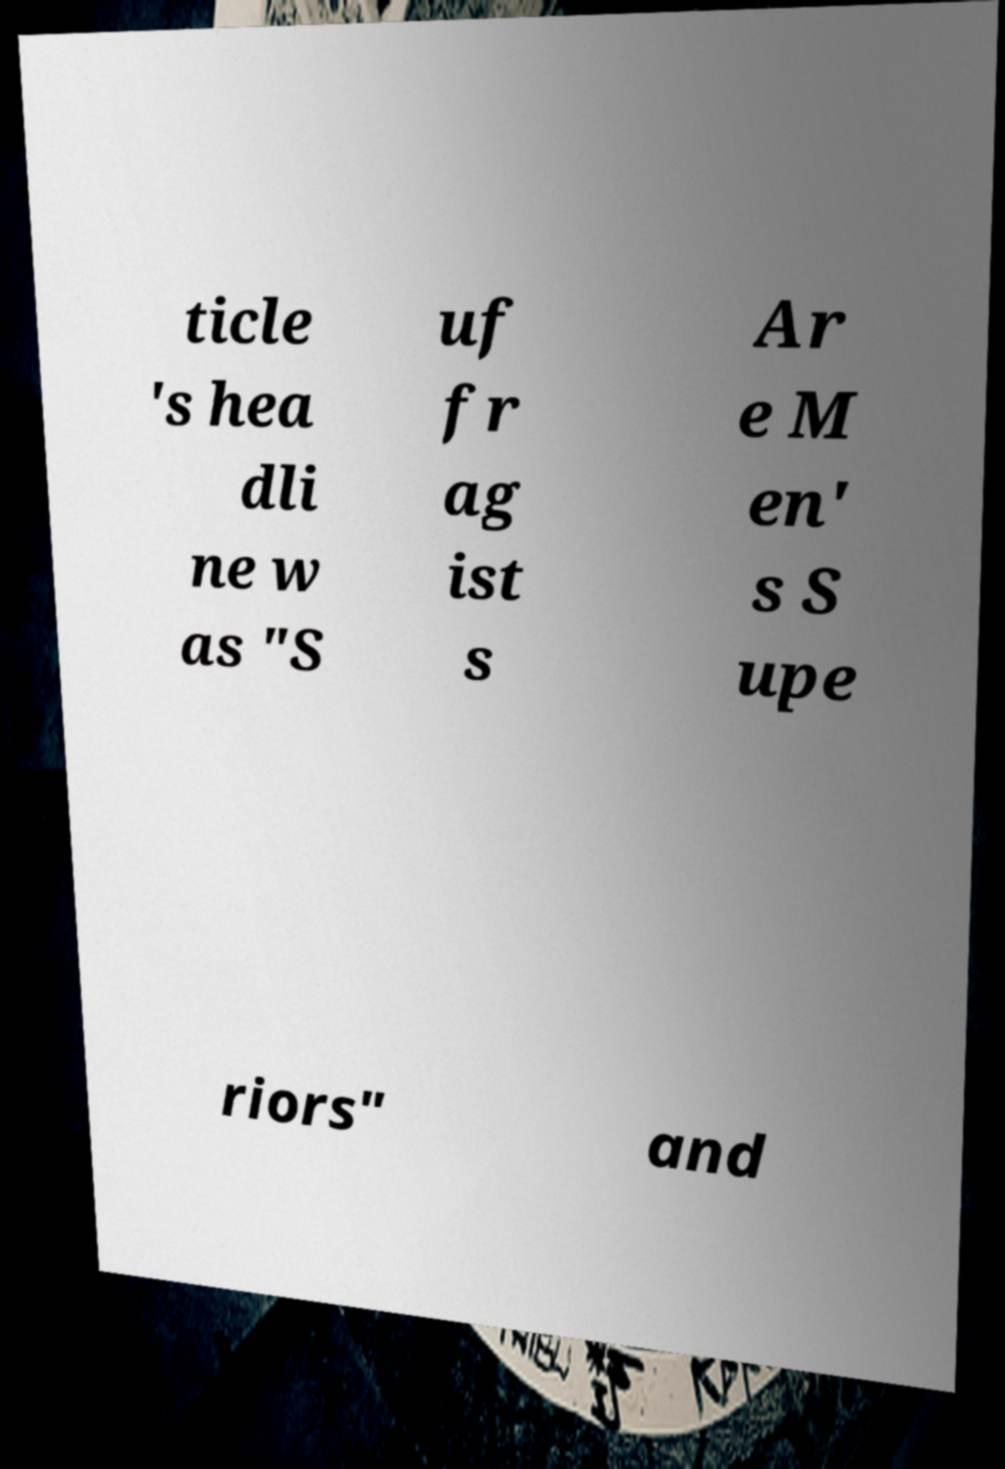Please read and relay the text visible in this image. What does it say? ticle 's hea dli ne w as "S uf fr ag ist s Ar e M en' s S upe riors" and 